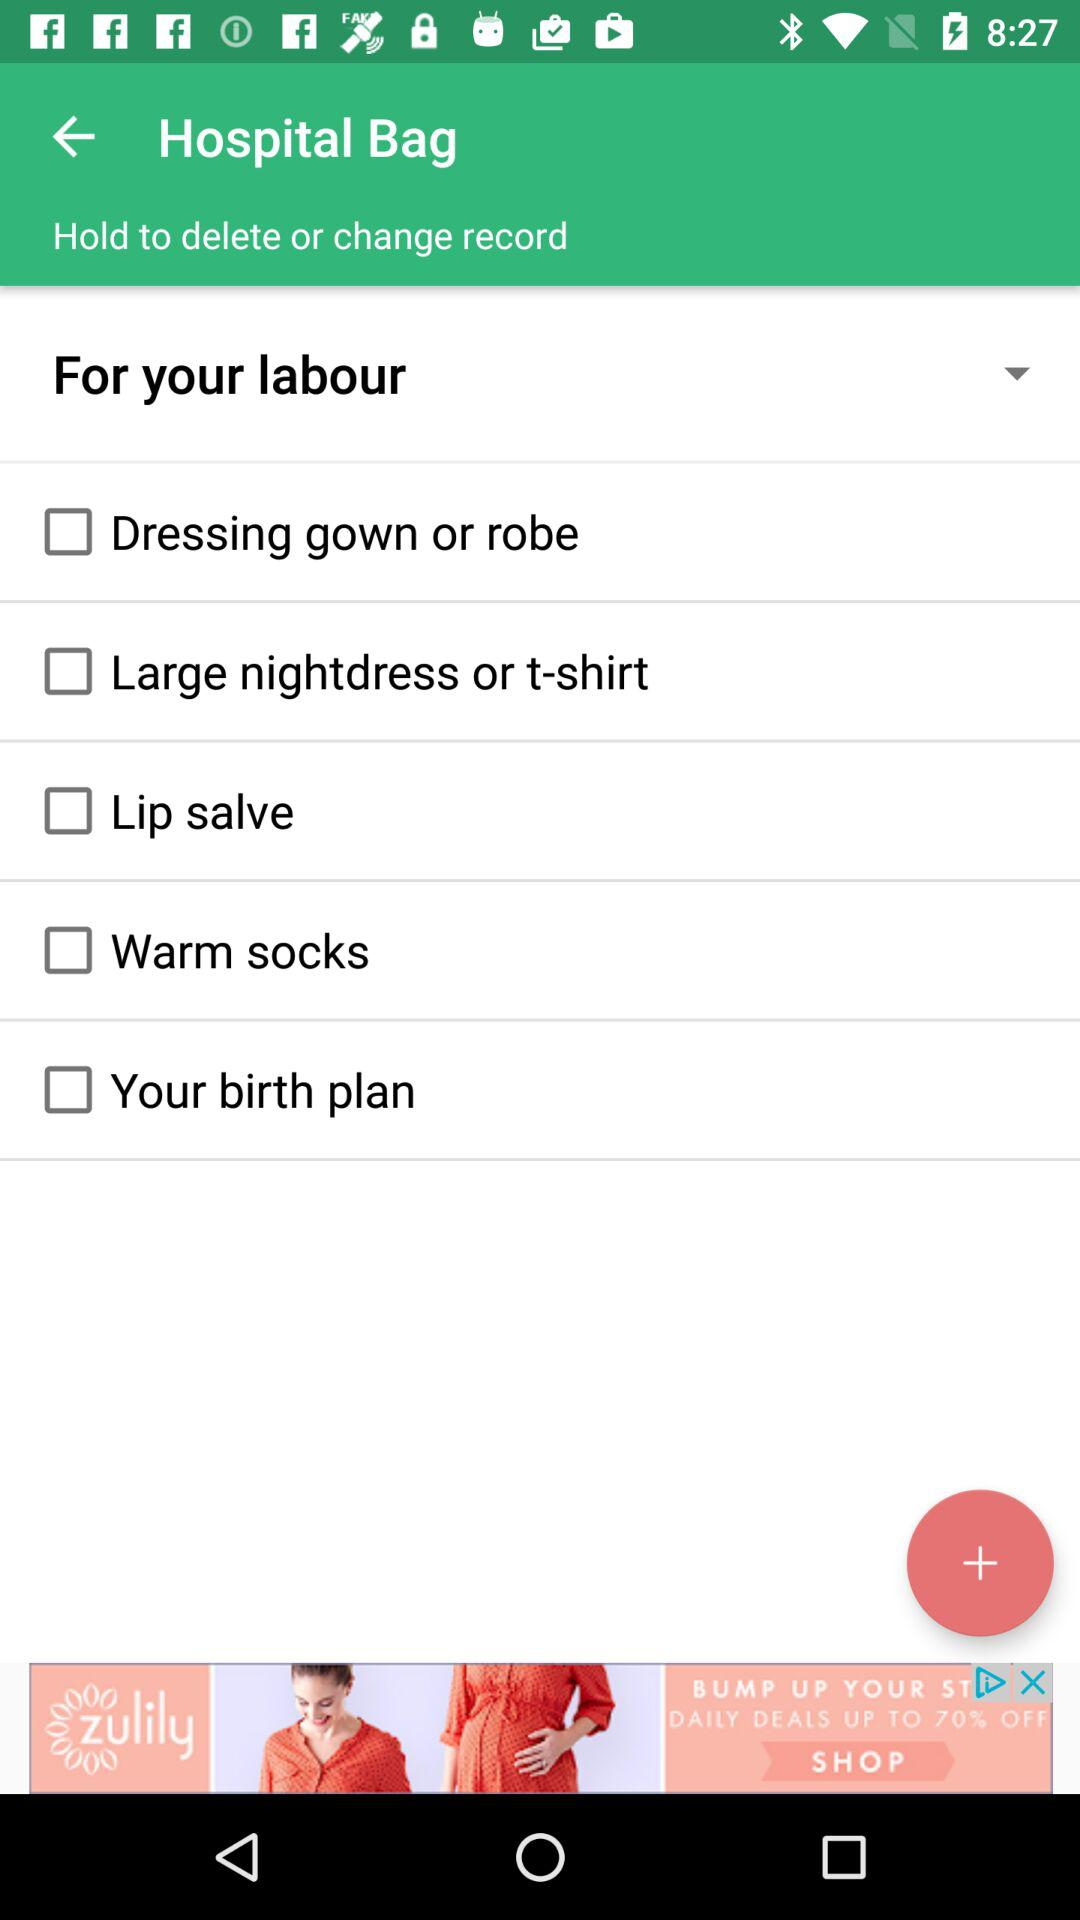What is the status of the "Lip salve"? The status of the "Lip salve" is" off". 